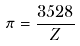<formula> <loc_0><loc_0><loc_500><loc_500>\pi = \frac { 3 5 2 8 } { Z }</formula> 